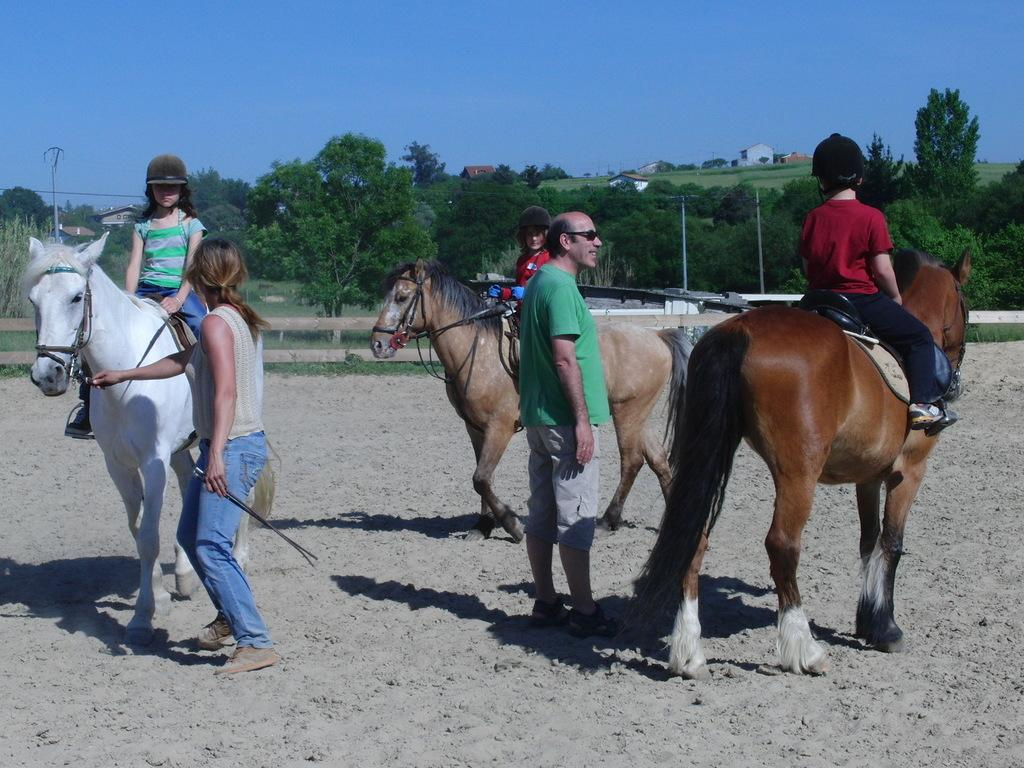What is happening in the image involving a group of people? There is a group of people in the image, and they are sitting on horses. Are there any children present in the image? Yes, there are kids in the image. What can be seen in the background of the image? There are trees, poles, and houses in the background of the image. What type of soap is being used by the kids in the image? There is no soap present in the image; the kids are sitting on horses. What agreement was reached by the people in the image? There is no mention of an agreement in the image; it simply shows a group of people and kids sitting on horses. 